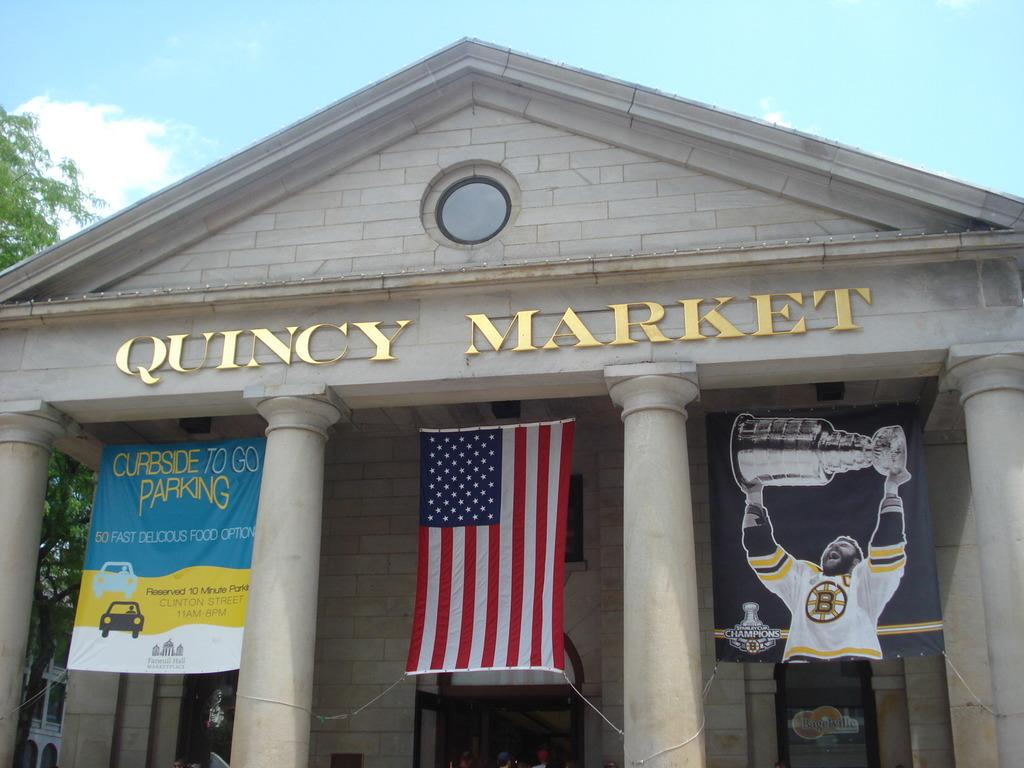<image>
Give a short and clear explanation of the subsequent image. A court house that says Quincy Market in gold letters has an American flag hanging in between pillars. 